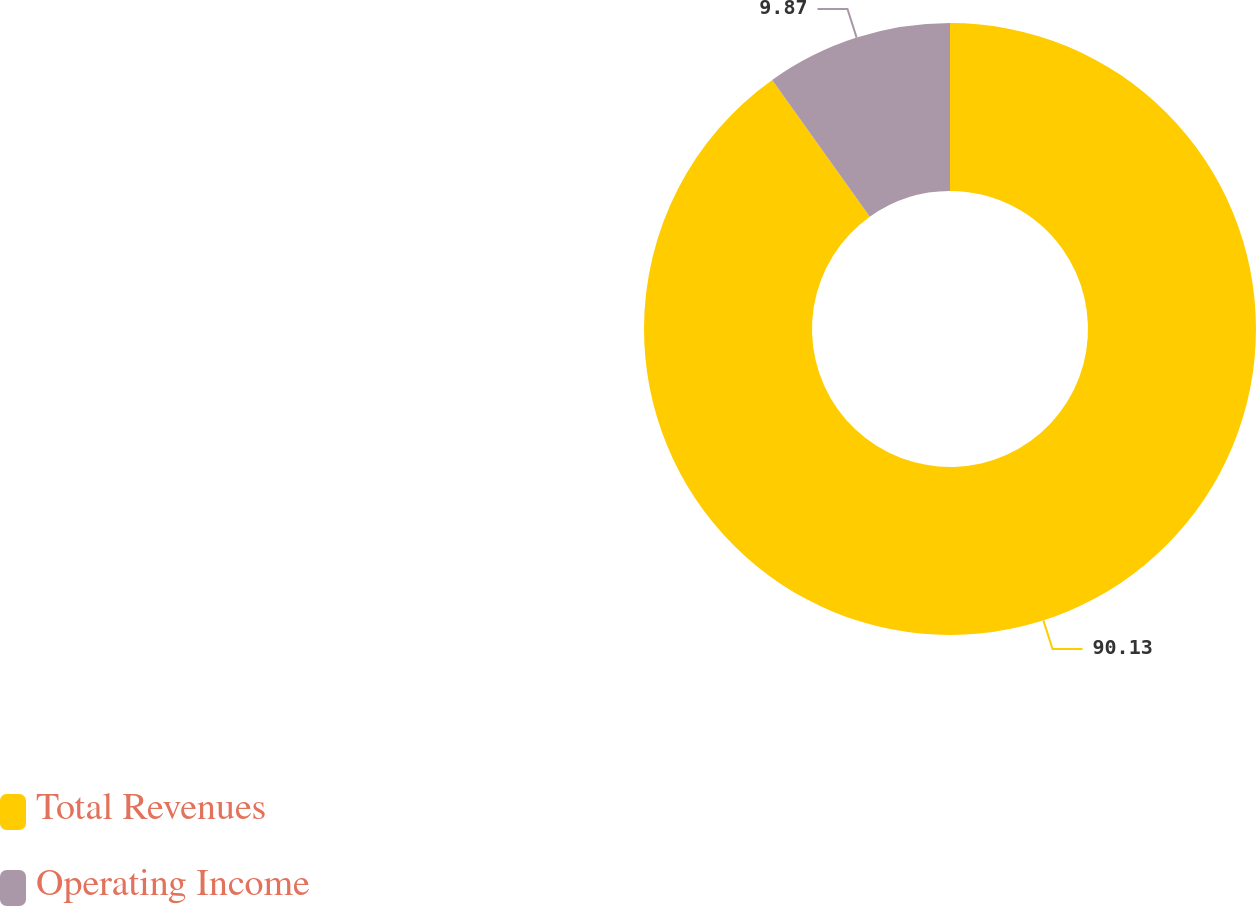Convert chart to OTSL. <chart><loc_0><loc_0><loc_500><loc_500><pie_chart><fcel>Total Revenues<fcel>Operating Income<nl><fcel>90.13%<fcel>9.87%<nl></chart> 